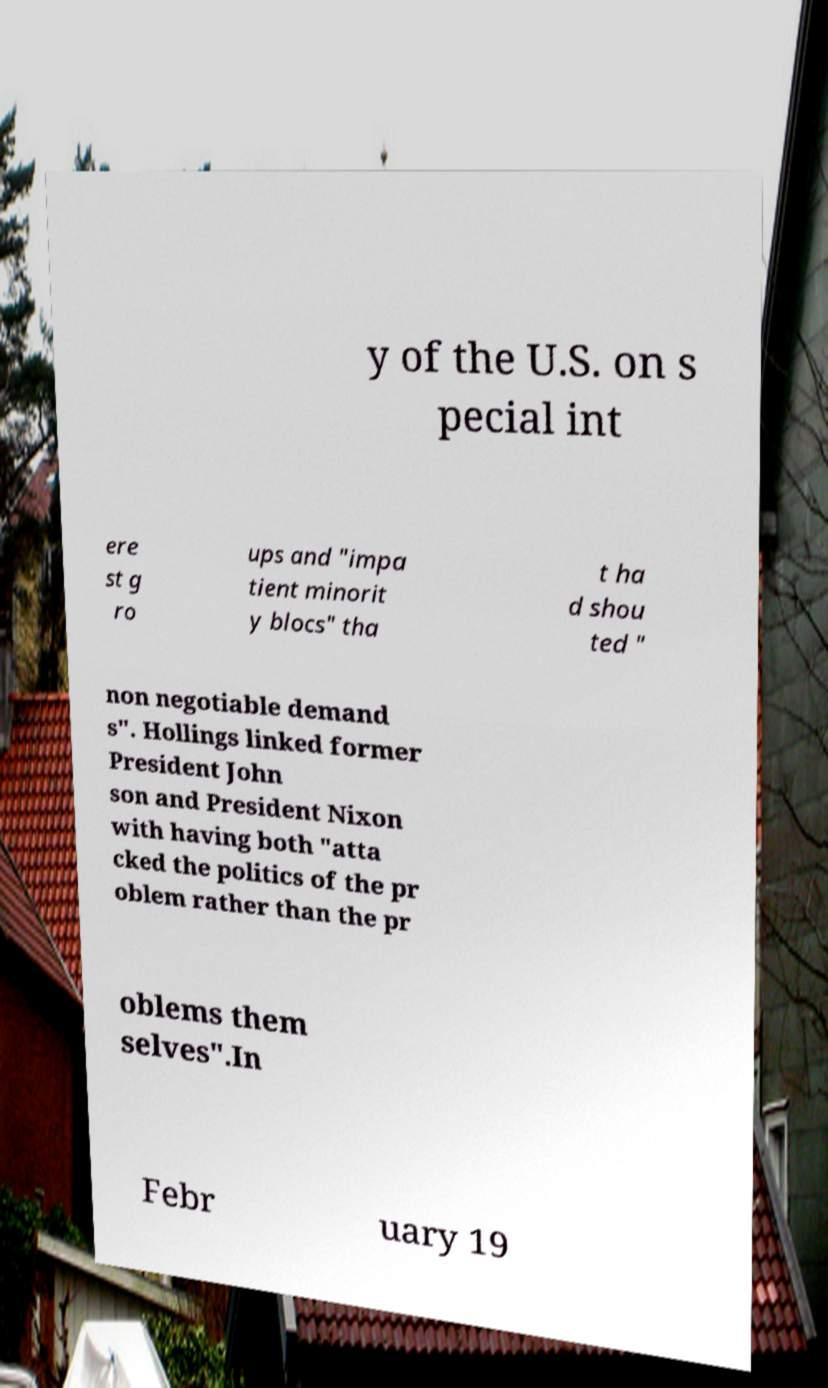There's text embedded in this image that I need extracted. Can you transcribe it verbatim? y of the U.S. on s pecial int ere st g ro ups and "impa tient minorit y blocs" tha t ha d shou ted " non negotiable demand s". Hollings linked former President John son and President Nixon with having both "atta cked the politics of the pr oblem rather than the pr oblems them selves".In Febr uary 19 